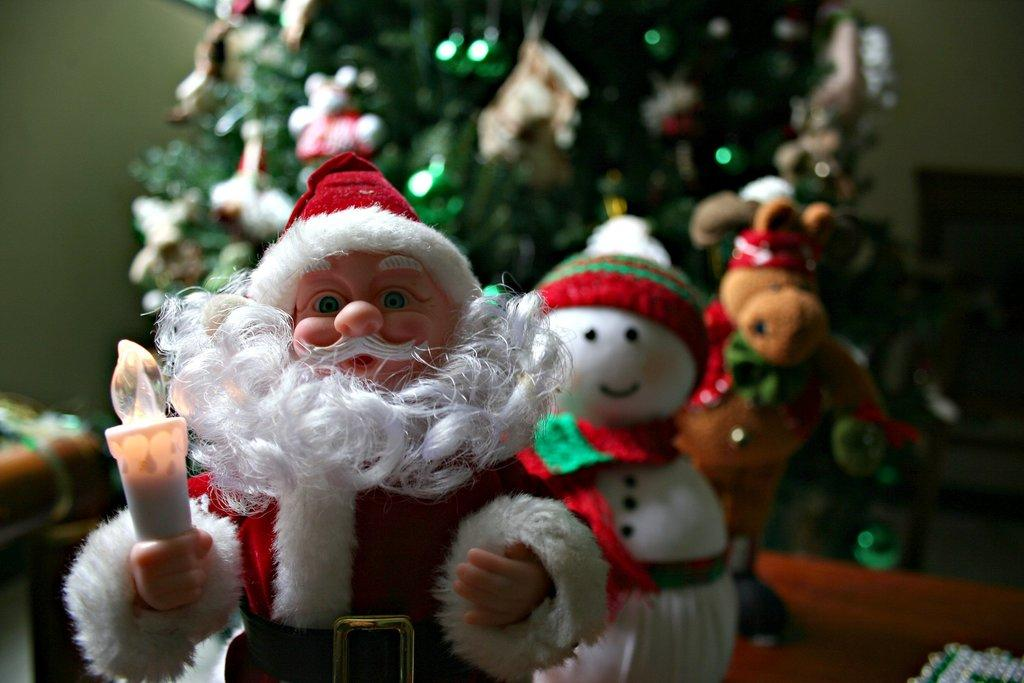What character is present in the image? There is a Santa Claus in the image. What can be seen in the background of the image? There are two toys and a Christmas tree in the background of the image. What type of car does Santa Claus drive in the image? There is no car present in the image; Santa Claus is on foot. 